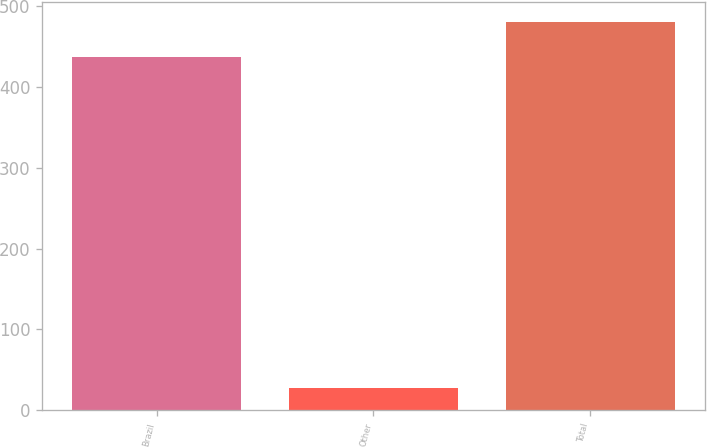<chart> <loc_0><loc_0><loc_500><loc_500><bar_chart><fcel>Brazil<fcel>Other<fcel>Total<nl><fcel>437<fcel>28<fcel>480.7<nl></chart> 